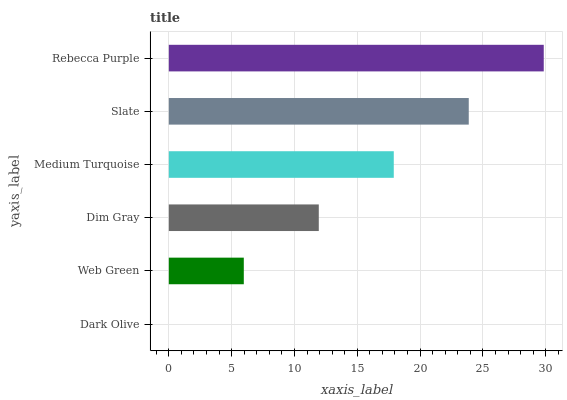Is Dark Olive the minimum?
Answer yes or no. Yes. Is Rebecca Purple the maximum?
Answer yes or no. Yes. Is Web Green the minimum?
Answer yes or no. No. Is Web Green the maximum?
Answer yes or no. No. Is Web Green greater than Dark Olive?
Answer yes or no. Yes. Is Dark Olive less than Web Green?
Answer yes or no. Yes. Is Dark Olive greater than Web Green?
Answer yes or no. No. Is Web Green less than Dark Olive?
Answer yes or no. No. Is Medium Turquoise the high median?
Answer yes or no. Yes. Is Dim Gray the low median?
Answer yes or no. Yes. Is Slate the high median?
Answer yes or no. No. Is Dark Olive the low median?
Answer yes or no. No. 